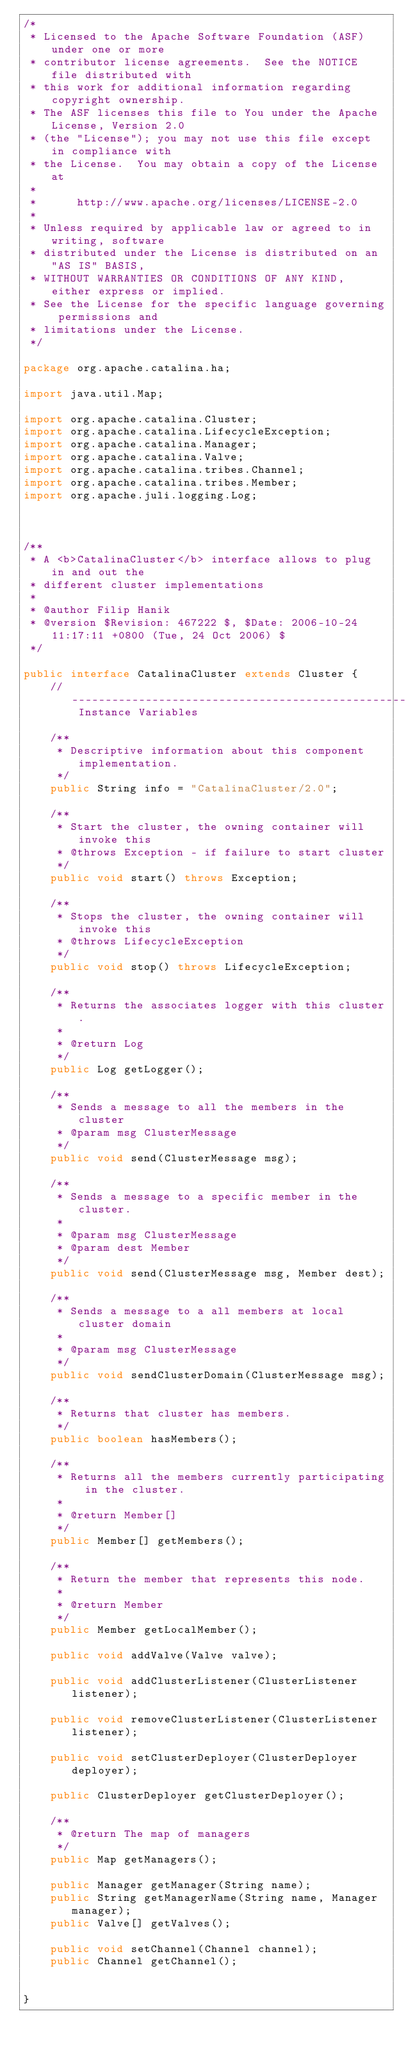Convert code to text. <code><loc_0><loc_0><loc_500><loc_500><_Java_>/*
 * Licensed to the Apache Software Foundation (ASF) under one or more
 * contributor license agreements.  See the NOTICE file distributed with
 * this work for additional information regarding copyright ownership.
 * The ASF licenses this file to You under the Apache License, Version 2.0
 * (the "License"); you may not use this file except in compliance with
 * the License.  You may obtain a copy of the License at
 * 
 *      http://www.apache.org/licenses/LICENSE-2.0
 * 
 * Unless required by applicable law or agreed to in writing, software
 * distributed under the License is distributed on an "AS IS" BASIS,
 * WITHOUT WARRANTIES OR CONDITIONS OF ANY KIND, either express or implied.
 * See the License for the specific language governing permissions and
 * limitations under the License.
 */

package org.apache.catalina.ha;

import java.util.Map;

import org.apache.catalina.Cluster;
import org.apache.catalina.LifecycleException;
import org.apache.catalina.Manager;
import org.apache.catalina.Valve;
import org.apache.catalina.tribes.Channel;
import org.apache.catalina.tribes.Member;
import org.apache.juli.logging.Log;



/**
 * A <b>CatalinaCluster</b> interface allows to plug in and out the 
 * different cluster implementations
 *
 * @author Filip Hanik
 * @version $Revision: 467222 $, $Date: 2006-10-24 11:17:11 +0800 (Tue, 24 Oct 2006) $
 */

public interface CatalinaCluster extends Cluster {
    // ----------------------------------------------------- Instance Variables

    /**
     * Descriptive information about this component implementation.
     */
    public String info = "CatalinaCluster/2.0";
    
    /**
     * Start the cluster, the owning container will invoke this
     * @throws Exception - if failure to start cluster
     */
    public void start() throws Exception;
    
    /**
     * Stops the cluster, the owning container will invoke this
     * @throws LifecycleException
     */
    public void stop() throws LifecycleException;
    
    /**
     * Returns the associates logger with this cluster.
     *
     * @return Log
     */
    public Log getLogger();
    
    /**
     * Sends a message to all the members in the cluster
     * @param msg ClusterMessage
     */
    public void send(ClusterMessage msg);
    
    /**
     * Sends a message to a specific member in the cluster.
     *
     * @param msg ClusterMessage
     * @param dest Member
     */
    public void send(ClusterMessage msg, Member dest);
    
    /**
     * Sends a message to a all members at local cluster domain
     *
     * @param msg ClusterMessage
     */
    public void sendClusterDomain(ClusterMessage msg);

    /**
     * Returns that cluster has members.
     */
    public boolean hasMembers();

    /**
     * Returns all the members currently participating in the cluster.
     *
     * @return Member[]
     */
    public Member[] getMembers();
    
    /**
     * Return the member that represents this node.
     *
     * @return Member
     */
    public Member getLocalMember();
    
    public void addValve(Valve valve);
    
    public void addClusterListener(ClusterListener listener);
    
    public void removeClusterListener(ClusterListener listener);
    
    public void setClusterDeployer(ClusterDeployer deployer);
    
    public ClusterDeployer getClusterDeployer();
    
    /**
     * @return The map of managers
     */
    public Map getManagers();

    public Manager getManager(String name);
    public String getManagerName(String name, Manager manager);
    public Valve[] getValves();
    
    public void setChannel(Channel channel);
    public Channel getChannel();
    

}
</code> 